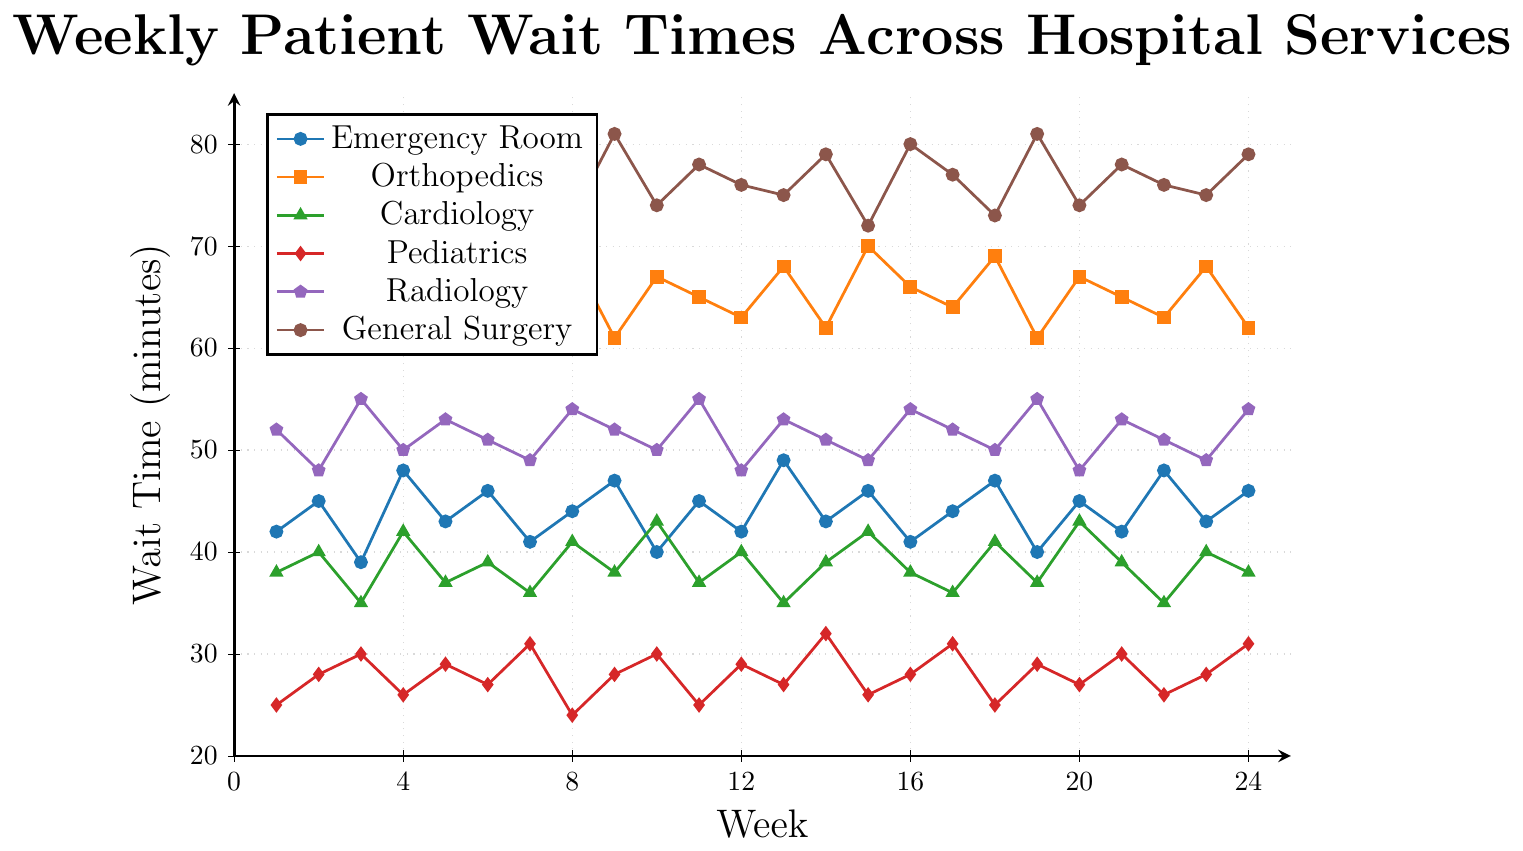What is the total wait time for Emergency Room and Cardiology in Week 10? First, identify the wait times for Emergency Room and Cardiology in Week 10 from the figure: Emergency Room is 40 minutes, and Cardiology is 43 minutes. Add them together: 40 + 43 = 83 minutes.
Answer: 83 minutes Which service had the highest wait time in Week 9? Look at the data points for Week 9 across all services: Emergency Room (47), Orthopedics (61), Cardiology (38), Pediatrics (28), Radiology (52), General Surgery (81). General Surgery has the highest wait time of 81 minutes.
Answer: General Surgery By how much did the wait time for Orthopedics increase from Week 3 to Week 4? In Week 3, Orthopedics had a wait time of 68 minutes, and in Week 4, it was 70 minutes. Calculate the difference: 70 - 68 = 2 minutes.
Answer: 2 minutes For which service and week is the wait time the lowest? Scan through the entire chart and identify the lowest data point. Pediatrics in Week 8 has the lowest wait time of 24 minutes.
Answer: Pediatrics in Week 8 What is the average wait time for Radiology over the 6-month period? Sum the wait times for Radiology over all 24 weeks: (52 + 48 + 55 + 50 + 53 + 51 + 49 + 54 + 52 + 50 + 55 + 48 + 53 + 51 + 49 + 54 + 52 + 50 + 55 + 48 + 53 + 51 + 49 + 54) = 1277. Then, divide by 24: 1277 / 24 ≈ 53.2 minutes.
Answer: 53.2 minutes During which week did Pediatrics have a wait time equal to the average wait time of General Surgery over the 6-month period? Calculate the average wait time of General Surgery: sum(78, 75, 72, 80, 76, 79, 77, 73, 81, 74, 78, 76, 75, 79, 72, 80, 77, 73, 81, 74, 78, 76, 75, 79) / 24 = 76 minutes. Identify the week when Pediatrics had a wait time of 76 minutes, which does not exist in the data.
Answer: None Which service has the most consistently stable wait times over the period? Identify the service with the smallest range of wait times. Radiology has wait times varying from 48 to 55, a range of 7. This is less than the ranges of the other services.
Answer: Radiology What was the wait time for Cardiology in Week 14, and how does it compare to the wait time for Pediatrics in Week 6? Identify Cardiology wait time in Week 14 (39 minutes) and Pediatrics wait time in Week 6 (27 minutes). The difference between them is: 39 - 27 = 12 minutes.
Answer: Cardiology in Week 14 is 12 minutes longer than Pediatrics in Week 6 